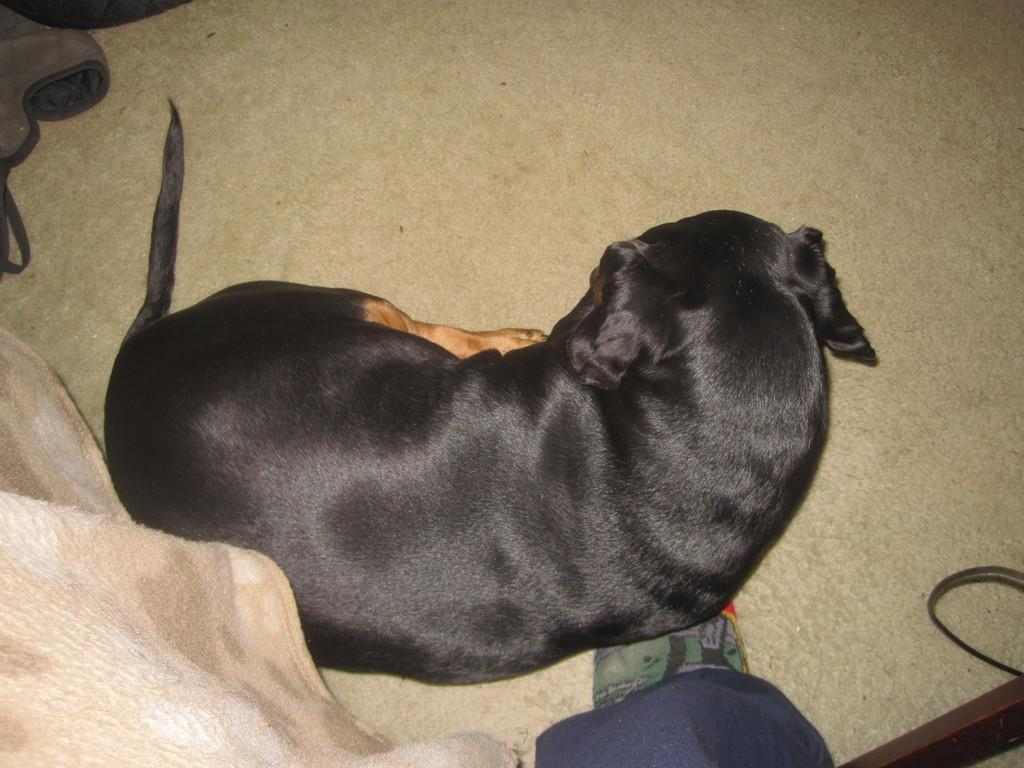What is on the floor in the image? There is a dog and a carpet on the floor in the image. What else can be seen in the bottom left of the image? There is a blanket in the bottom left of the image. Can you describe any part of a person in the image? A person's leg is visible in the bottom of the image. What type of force is being applied to the carpet in the image? There is no indication of any force being applied to the carpet in the image. What design elements can be seen in the dog's fur in the image? The image does not provide enough detail to analyze the design elements in the dog's fur. 